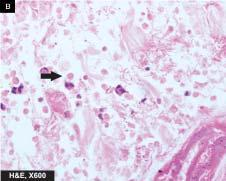where are trophozoites of entamoeba histolytica seen?
Answer the question using a single word or phrase. At the margin of ulcer 